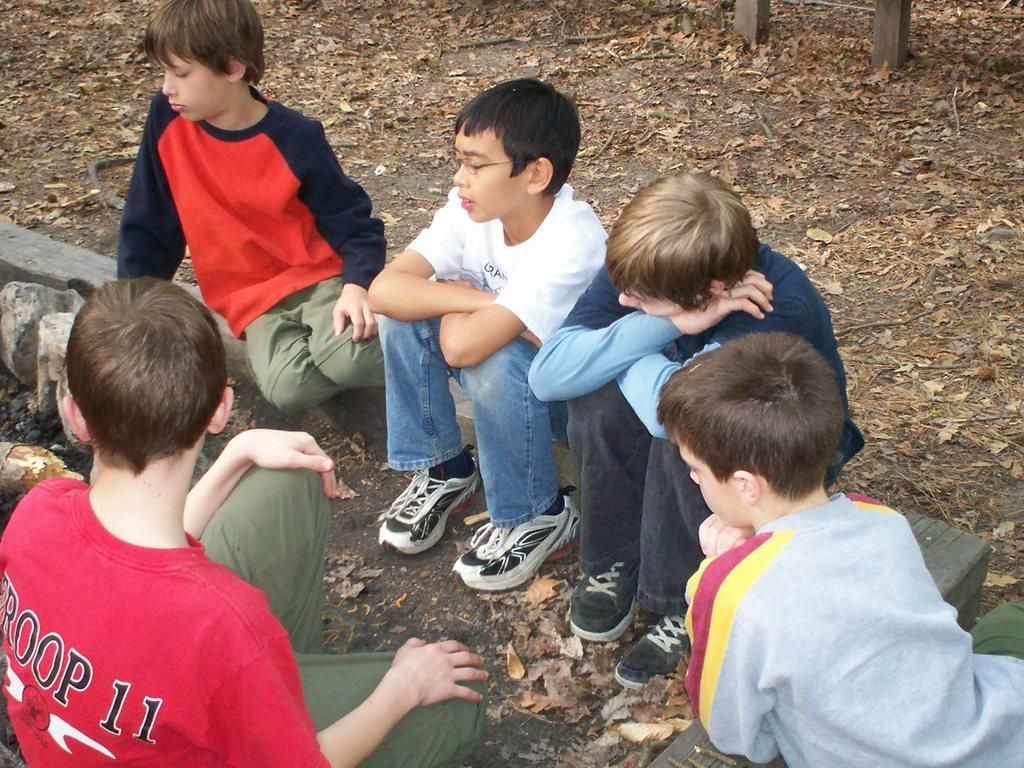What are the boys in the image doing? The boys are sitting on the ground in the image. What can be seen in the background of the image? There are leaves visible in the background of the image. What type of screw can be seen in the image? There is no screw present in the image; it features boys sitting on the ground with leaves in the background. 